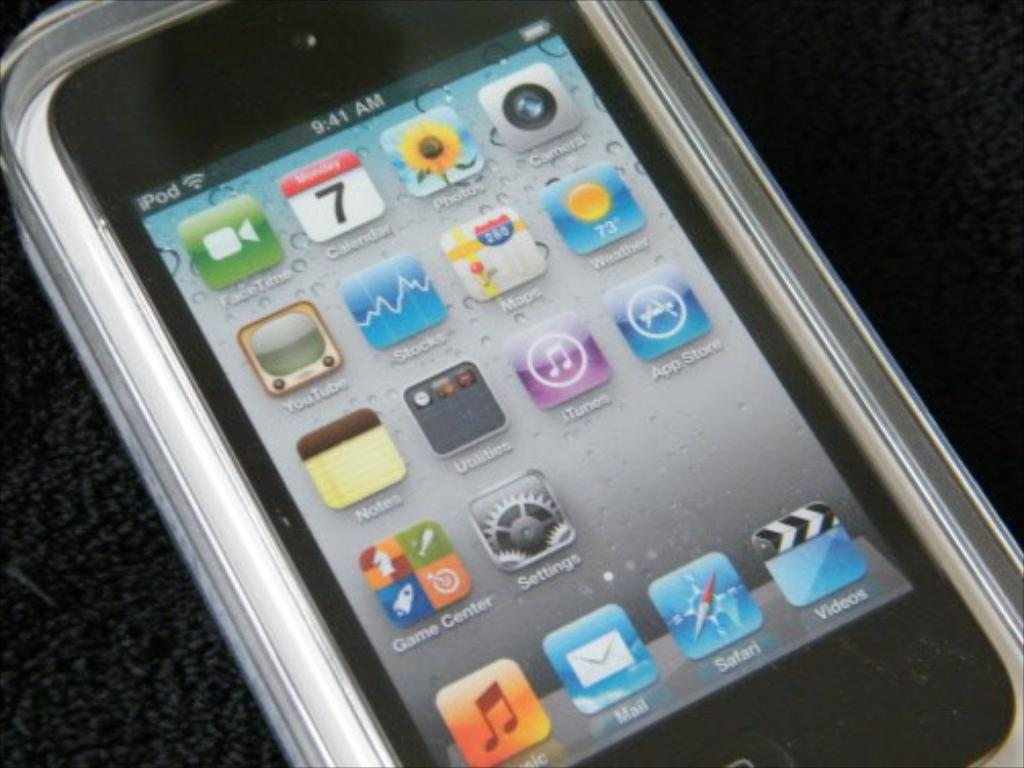<image>
Render a clear and concise summary of the photo. A phone which shows that it is the 7th of the current month. 